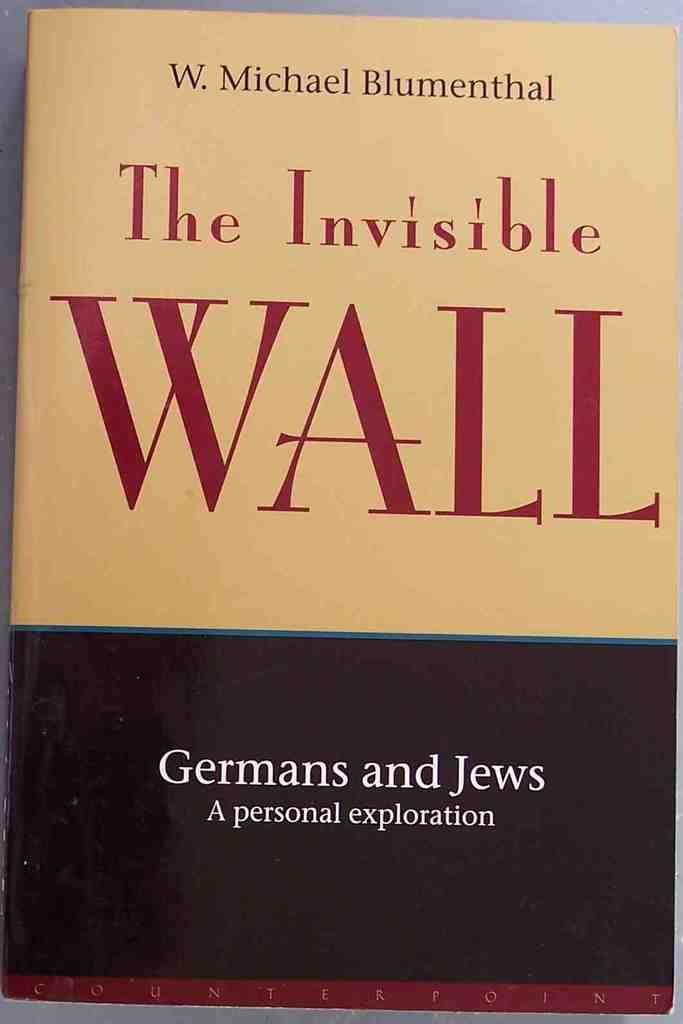<image>
Share a concise interpretation of the image provided. A copy of the book "the invisible wall" by W. Michael Blumenthal. 